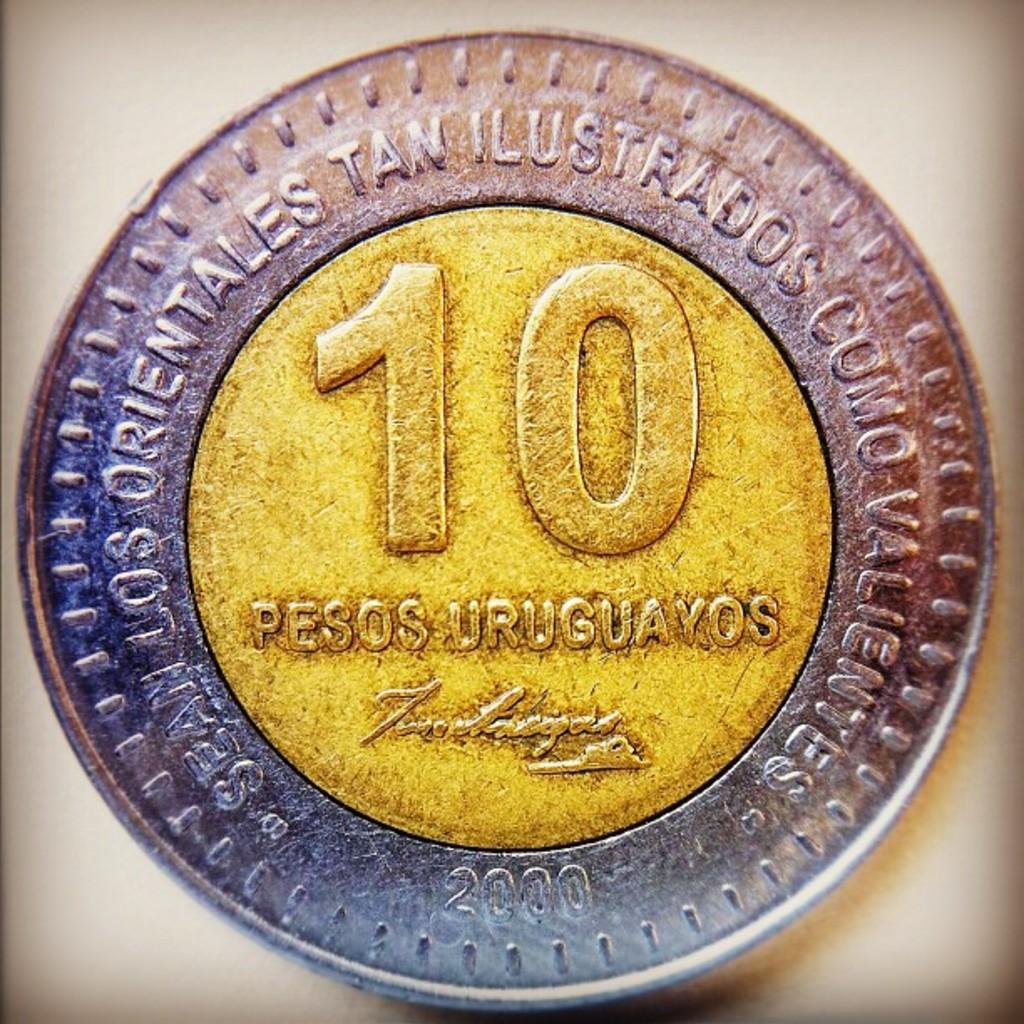Provide a one-sentence caption for the provided image. A 10 cent peso that is silver and yellow is being displayed. 